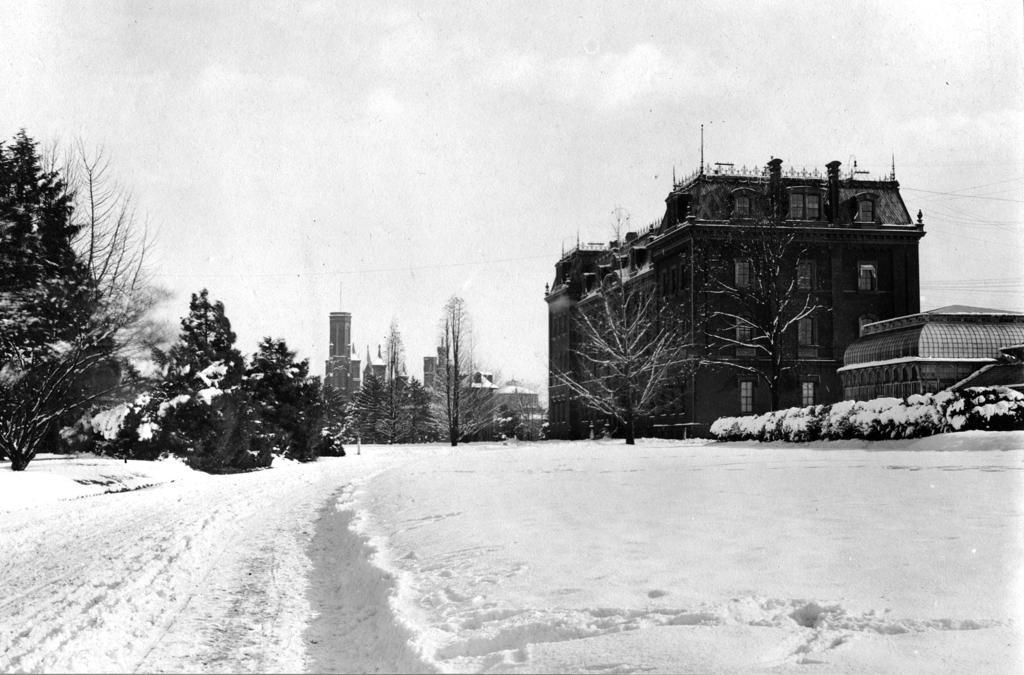Could you give a brief overview of what you see in this image? In this image we can see the buildings, windows, trees, dried trees, snow, at the top we can see the sky. 